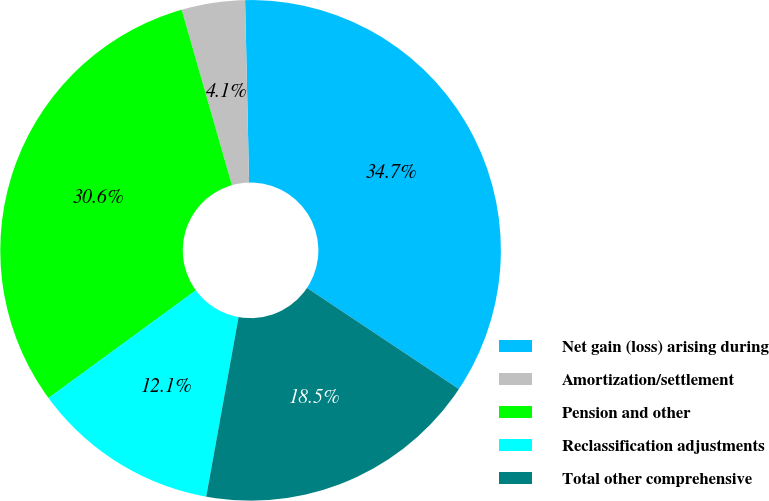Convert chart to OTSL. <chart><loc_0><loc_0><loc_500><loc_500><pie_chart><fcel>Net gain (loss) arising during<fcel>Amortization/settlement<fcel>Pension and other<fcel>Reclassification adjustments<fcel>Total other comprehensive<nl><fcel>34.7%<fcel>4.09%<fcel>30.61%<fcel>12.12%<fcel>18.49%<nl></chart> 